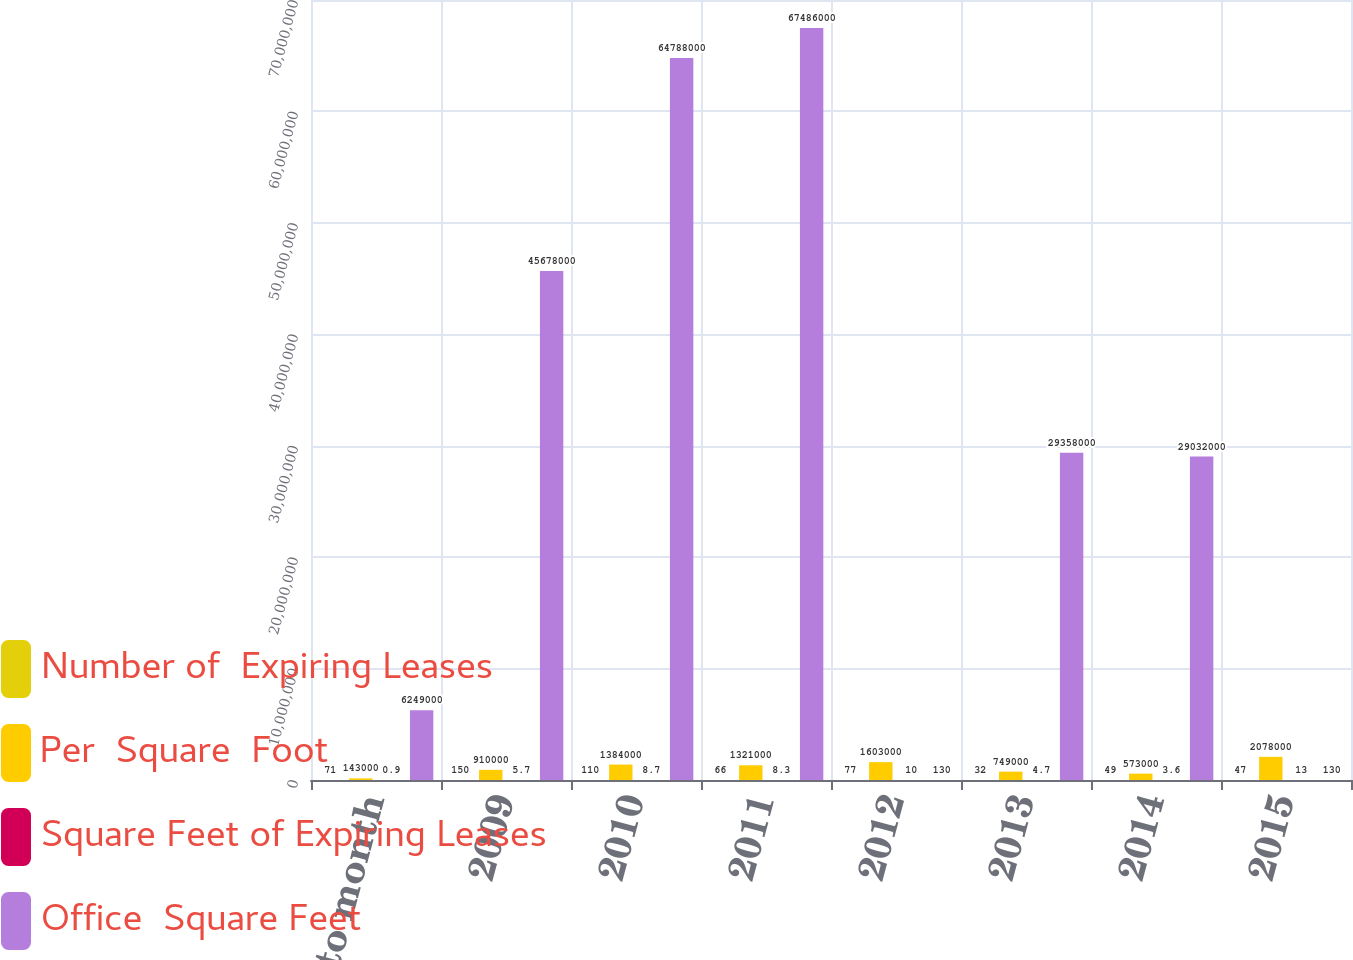Convert chart to OTSL. <chart><loc_0><loc_0><loc_500><loc_500><stacked_bar_chart><ecel><fcel>Month to month<fcel>2009<fcel>2010<fcel>2011<fcel>2012<fcel>2013<fcel>2014<fcel>2015<nl><fcel>Number of  Expiring Leases<fcel>71<fcel>150<fcel>110<fcel>66<fcel>77<fcel>32<fcel>49<fcel>47<nl><fcel>Per  Square  Foot<fcel>143000<fcel>910000<fcel>1.384e+06<fcel>1.321e+06<fcel>1.603e+06<fcel>749000<fcel>573000<fcel>2.078e+06<nl><fcel>Square Feet of Expiring Leases<fcel>0.9<fcel>5.7<fcel>8.7<fcel>8.3<fcel>10<fcel>4.7<fcel>3.6<fcel>13<nl><fcel>Office  Square Feet<fcel>6.249e+06<fcel>4.5678e+07<fcel>6.4788e+07<fcel>6.7486e+07<fcel>130<fcel>2.9358e+07<fcel>2.9032e+07<fcel>130<nl></chart> 